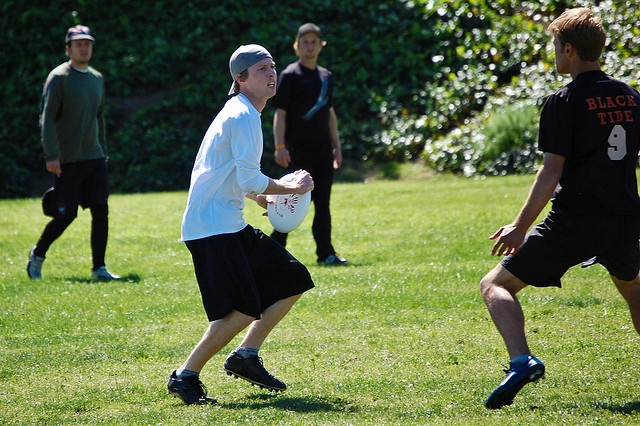Describe the objects in this image and their specific colors. I can see people in black, maroon, olive, and gray tones, people in black, lightblue, gray, and white tones, people in black, blue, gray, and maroon tones, people in black, gray, and maroon tones, and frisbee in black, darkgray, gray, and white tones in this image. 